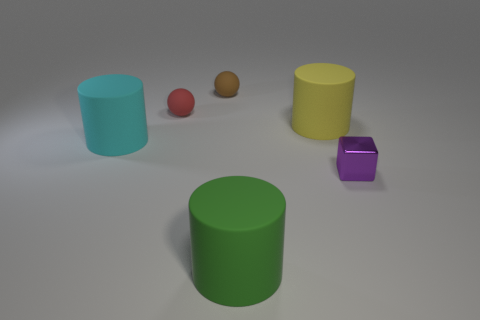Subtract all big cyan cylinders. How many cylinders are left? 2 Add 3 large cyan rubber things. How many objects exist? 9 Subtract all spheres. How many objects are left? 4 Subtract all brown cylinders. Subtract all purple balls. How many cylinders are left? 3 Subtract all big cyan rubber cubes. Subtract all large green rubber objects. How many objects are left? 5 Add 3 small blocks. How many small blocks are left? 4 Add 1 tiny metallic cubes. How many tiny metallic cubes exist? 2 Subtract 0 green balls. How many objects are left? 6 